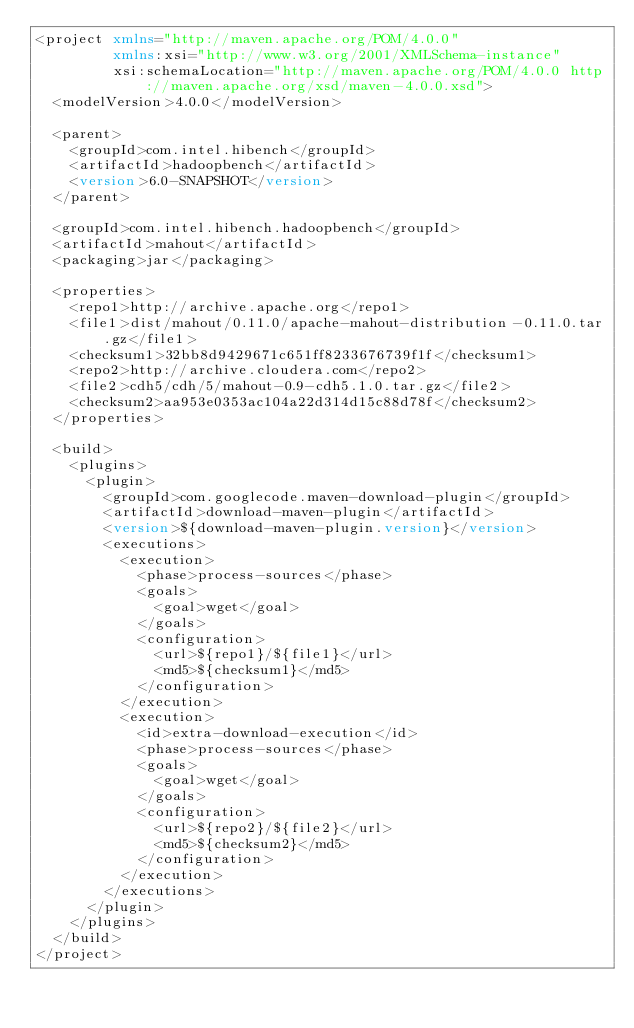Convert code to text. <code><loc_0><loc_0><loc_500><loc_500><_XML_><project xmlns="http://maven.apache.org/POM/4.0.0"
         xmlns:xsi="http://www.w3.org/2001/XMLSchema-instance"
         xsi:schemaLocation="http://maven.apache.org/POM/4.0.0 http://maven.apache.org/xsd/maven-4.0.0.xsd">
  <modelVersion>4.0.0</modelVersion>

  <parent>
    <groupId>com.intel.hibench</groupId>
    <artifactId>hadoopbench</artifactId>
    <version>6.0-SNAPSHOT</version>
  </parent>

  <groupId>com.intel.hibench.hadoopbench</groupId>
  <artifactId>mahout</artifactId>
  <packaging>jar</packaging>

  <properties>
    <repo1>http://archive.apache.org</repo1>
    <file1>dist/mahout/0.11.0/apache-mahout-distribution-0.11.0.tar.gz</file1>
    <checksum1>32bb8d9429671c651ff8233676739f1f</checksum1>
    <repo2>http://archive.cloudera.com</repo2>
    <file2>cdh5/cdh/5/mahout-0.9-cdh5.1.0.tar.gz</file2>
    <checksum2>aa953e0353ac104a22d314d15c88d78f</checksum2>
  </properties>

  <build>
    <plugins>
      <plugin>
        <groupId>com.googlecode.maven-download-plugin</groupId>
        <artifactId>download-maven-plugin</artifactId>
        <version>${download-maven-plugin.version}</version>
        <executions>
          <execution>
            <phase>process-sources</phase>
            <goals>
              <goal>wget</goal>
            </goals>
            <configuration>
              <url>${repo1}/${file1}</url>
              <md5>${checksum1}</md5>
            </configuration>
          </execution>
          <execution>
            <id>extra-download-execution</id>
            <phase>process-sources</phase>
            <goals>
              <goal>wget</goal>
            </goals>
            <configuration>
              <url>${repo2}/${file2}</url>
              <md5>${checksum2}</md5>
            </configuration>
          </execution>
        </executions>
      </plugin>
    </plugins>
  </build>
</project>
</code> 